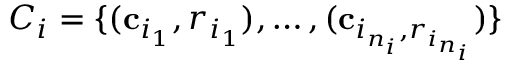<formula> <loc_0><loc_0><loc_500><loc_500>C _ { i } = \{ ( c _ { i _ { 1 } } , r _ { i _ { 1 } } ) , \dots , ( c _ { i _ { n _ { i } } , r _ { i _ { n _ { i } } } } ) \}</formula> 